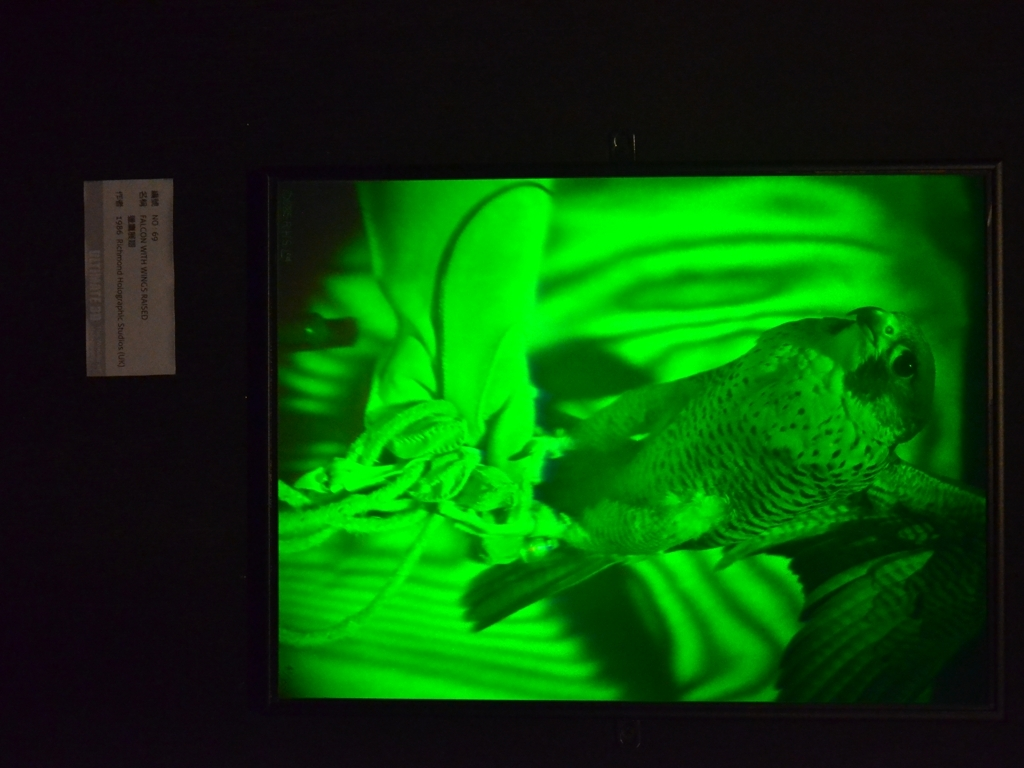Could you describe the subject captured in this framed image? Certainly, the subject within this framed image appears to be a bird, likely in mid-flap or motion, accentuated by the dynamic green lighting that contours its feathers and body, thus giving it a sense of vitality and movement. 